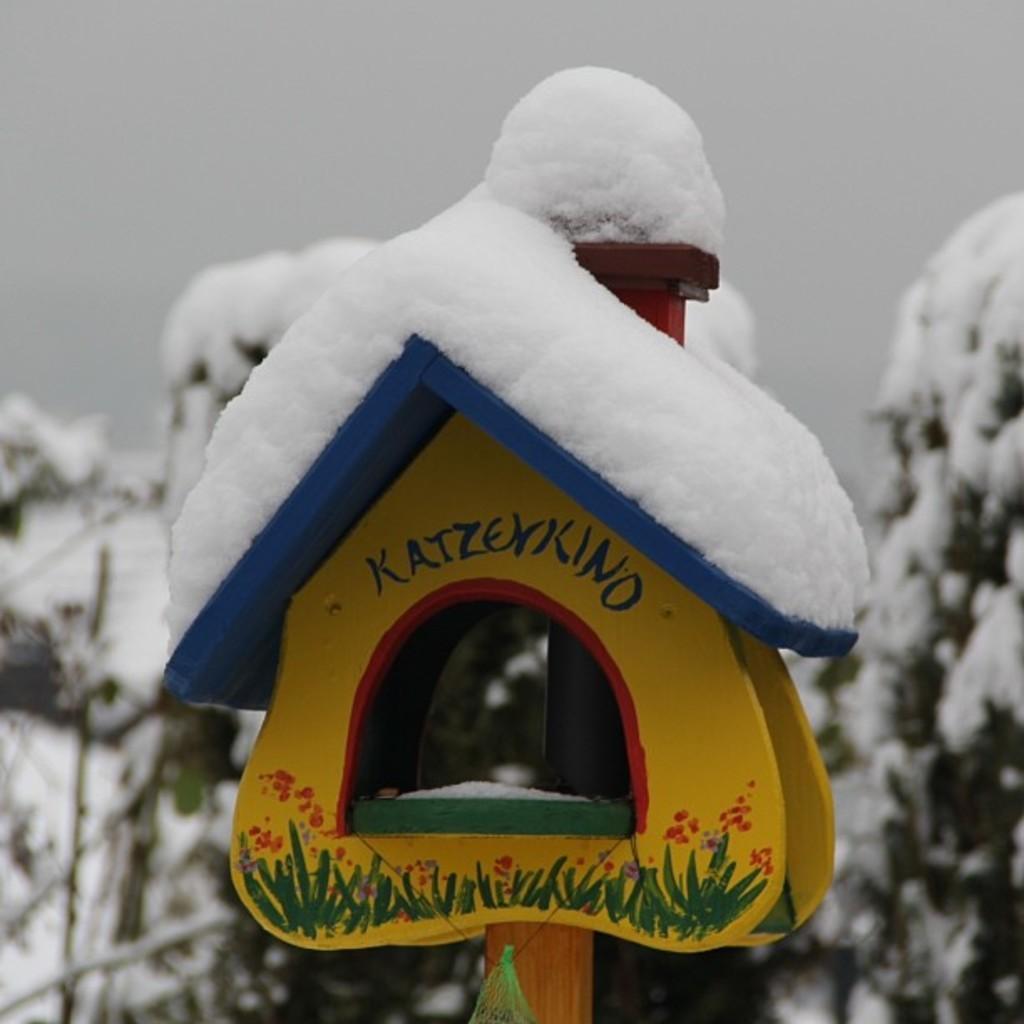Can you describe this image briefly? In this picture there is an artificial house on the pole and there is snow on the house. At the back there are trees and there is snow. At the top there is sky. 